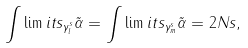Convert formula to latex. <formula><loc_0><loc_0><loc_500><loc_500>\int \lim i t s _ { \gamma ^ { s } _ { l } } \tilde { \alpha } = \int \lim i t s _ { \gamma ^ { s } _ { m } } \tilde { \alpha } = 2 N s ,</formula> 